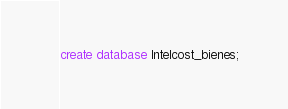<code> <loc_0><loc_0><loc_500><loc_500><_SQL_>create database Intelcost_bienes;</code> 